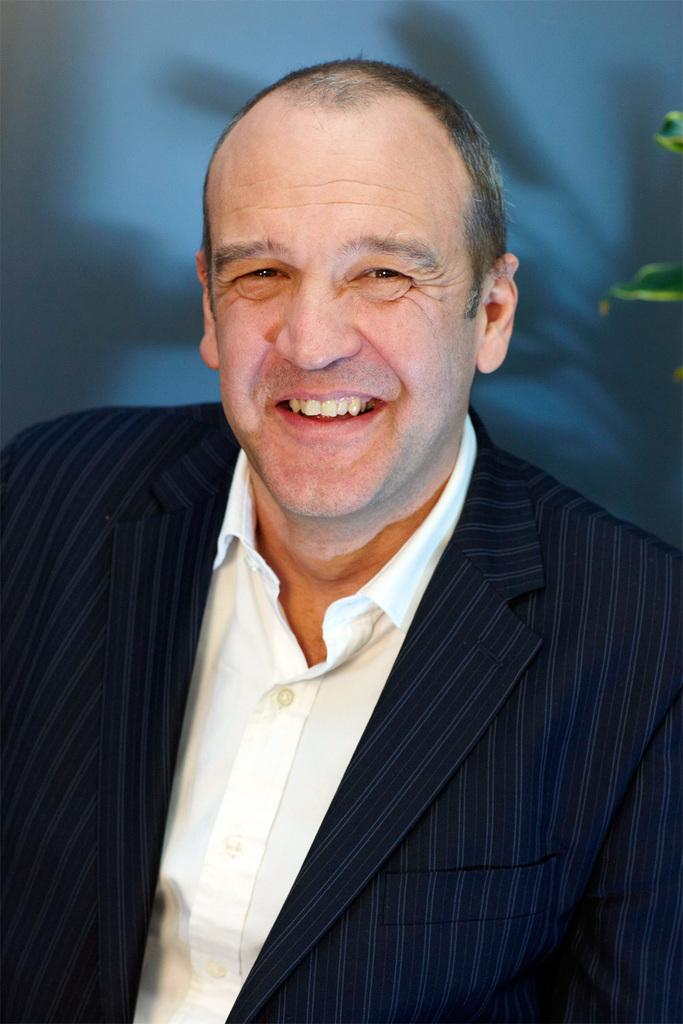What is present in the image? There is a man in the image. What is the man doing in the image? The man is smiling. What is the man wearing on his upper body? The man is wearing a black coat and a white shirt. What type of hose is the man using to water the plants in the image? There is no hose or plants present in the image; it features a man wearing a black coat and a white shirt. What type of boundary is visible in the image? There is no boundary visible in the image. 